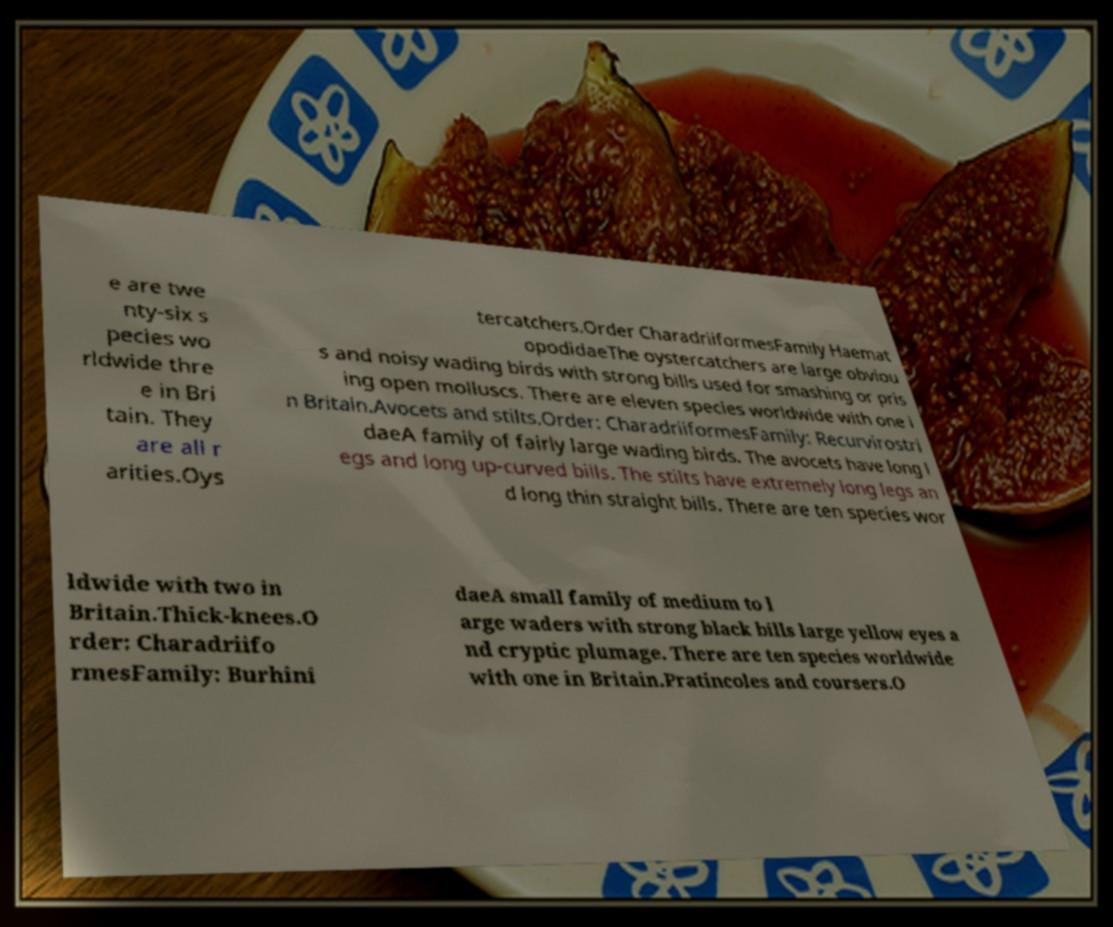Can you accurately transcribe the text from the provided image for me? e are twe nty-six s pecies wo rldwide thre e in Bri tain. They are all r arities.Oys tercatchers.Order CharadriiformesFamily Haemat opodidaeThe oystercatchers are large obviou s and noisy wading birds with strong bills used for smashing or pris ing open molluscs. There are eleven species worldwide with one i n Britain.Avocets and stilts.Order: CharadriiformesFamily: Recurvirostri daeA family of fairly large wading birds. The avocets have long l egs and long up-curved bills. The stilts have extremely long legs an d long thin straight bills. There are ten species wor ldwide with two in Britain.Thick-knees.O rder: Charadriifo rmesFamily: Burhini daeA small family of medium to l arge waders with strong black bills large yellow eyes a nd cryptic plumage. There are ten species worldwide with one in Britain.Pratincoles and coursers.O 